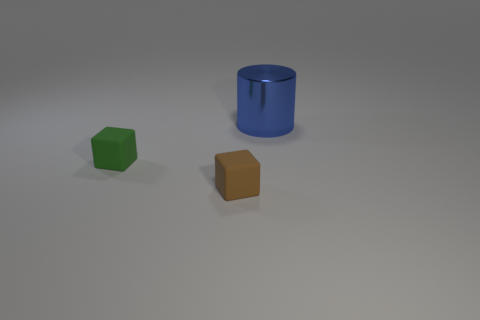What is the color of the other small object that is the same shape as the brown rubber object?
Your answer should be compact. Green. Is the number of green things in front of the tiny brown rubber thing greater than the number of red rubber things?
Make the answer very short. No. There is a blue object; is it the same shape as the tiny matte thing behind the small brown rubber object?
Make the answer very short. No. Is there any other thing that has the same size as the green thing?
Your answer should be very brief. Yes. What is the size of the brown rubber object that is the same shape as the green thing?
Keep it short and to the point. Small. Are there more tiny green metal balls than green matte things?
Your response must be concise. No. Do the small brown rubber thing and the big blue object have the same shape?
Offer a very short reply. No. What is the material of the small object behind the small rubber block that is in front of the small green thing?
Make the answer very short. Rubber. Is the size of the blue metallic thing the same as the green rubber object?
Keep it short and to the point. No. There is a rubber object that is in front of the green object; is there a tiny brown object behind it?
Give a very brief answer. No. 